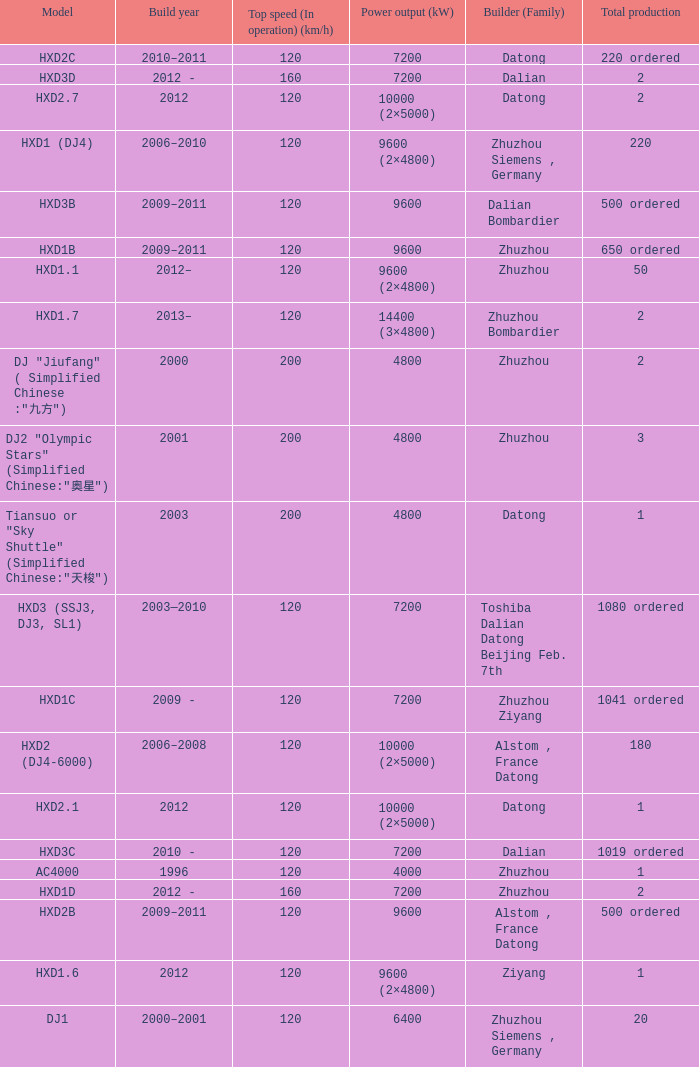What is the power output (kw) of model hxd3d? 7200.0. 